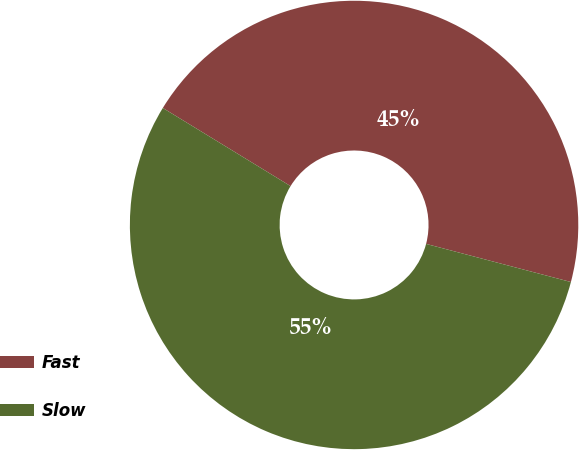Convert chart. <chart><loc_0><loc_0><loc_500><loc_500><pie_chart><fcel>Fast<fcel>Slow<nl><fcel>45.36%<fcel>54.64%<nl></chart> 